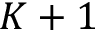<formula> <loc_0><loc_0><loc_500><loc_500>K + 1</formula> 